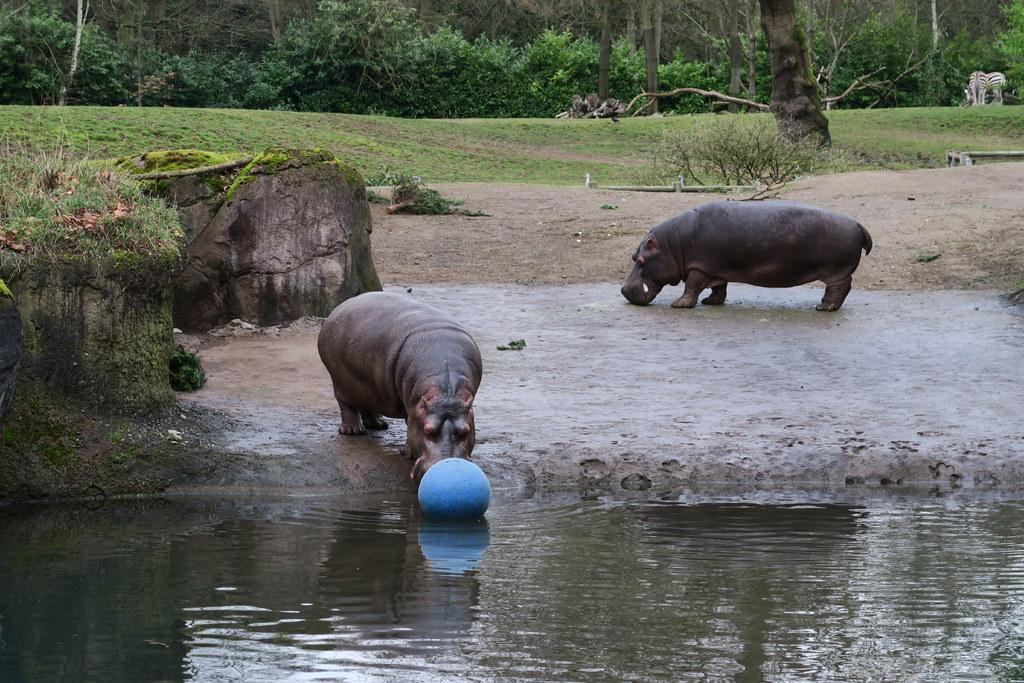What types of living organisms can be seen in the image? Animals, trees, and plants are visible in the image. What is the primary element in the image? Water is visible in the image. What object can be seen in the image? There is an object in the image. What type of terrain is present in the image? Rocks and grass are visible in the image. What type of button can be seen in the image? There is no button present in the image. How many things can be measured in the image? The image does not depict any objects or elements that can be measured. 